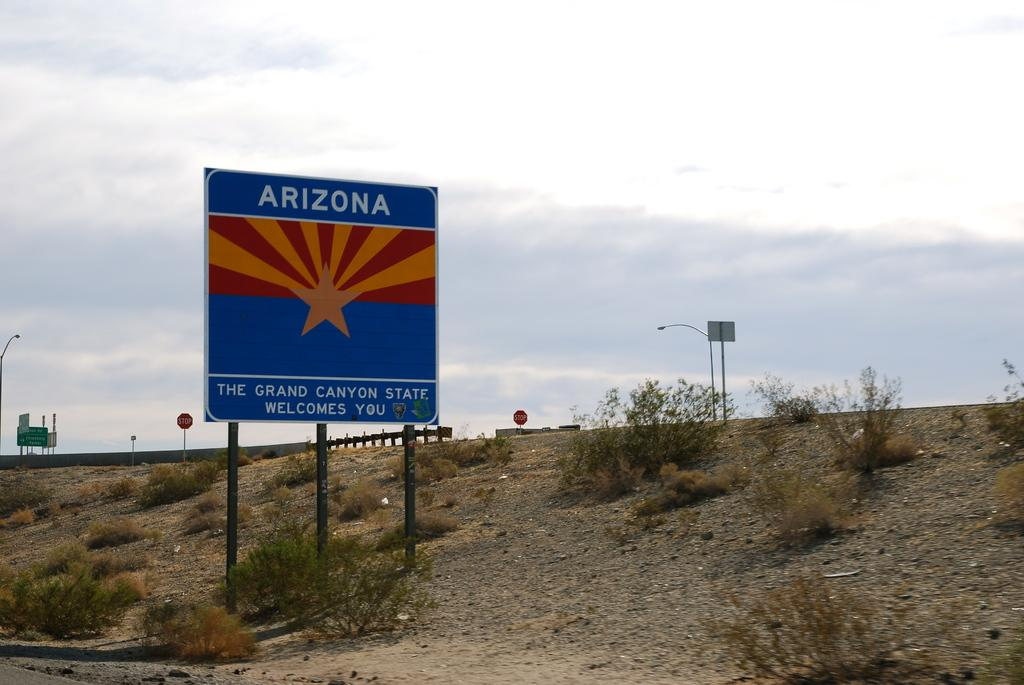<image>
Create a compact narrative representing the image presented. a road sign for Arizona on the side of a road 